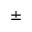<formula> <loc_0><loc_0><loc_500><loc_500>\pm</formula> 